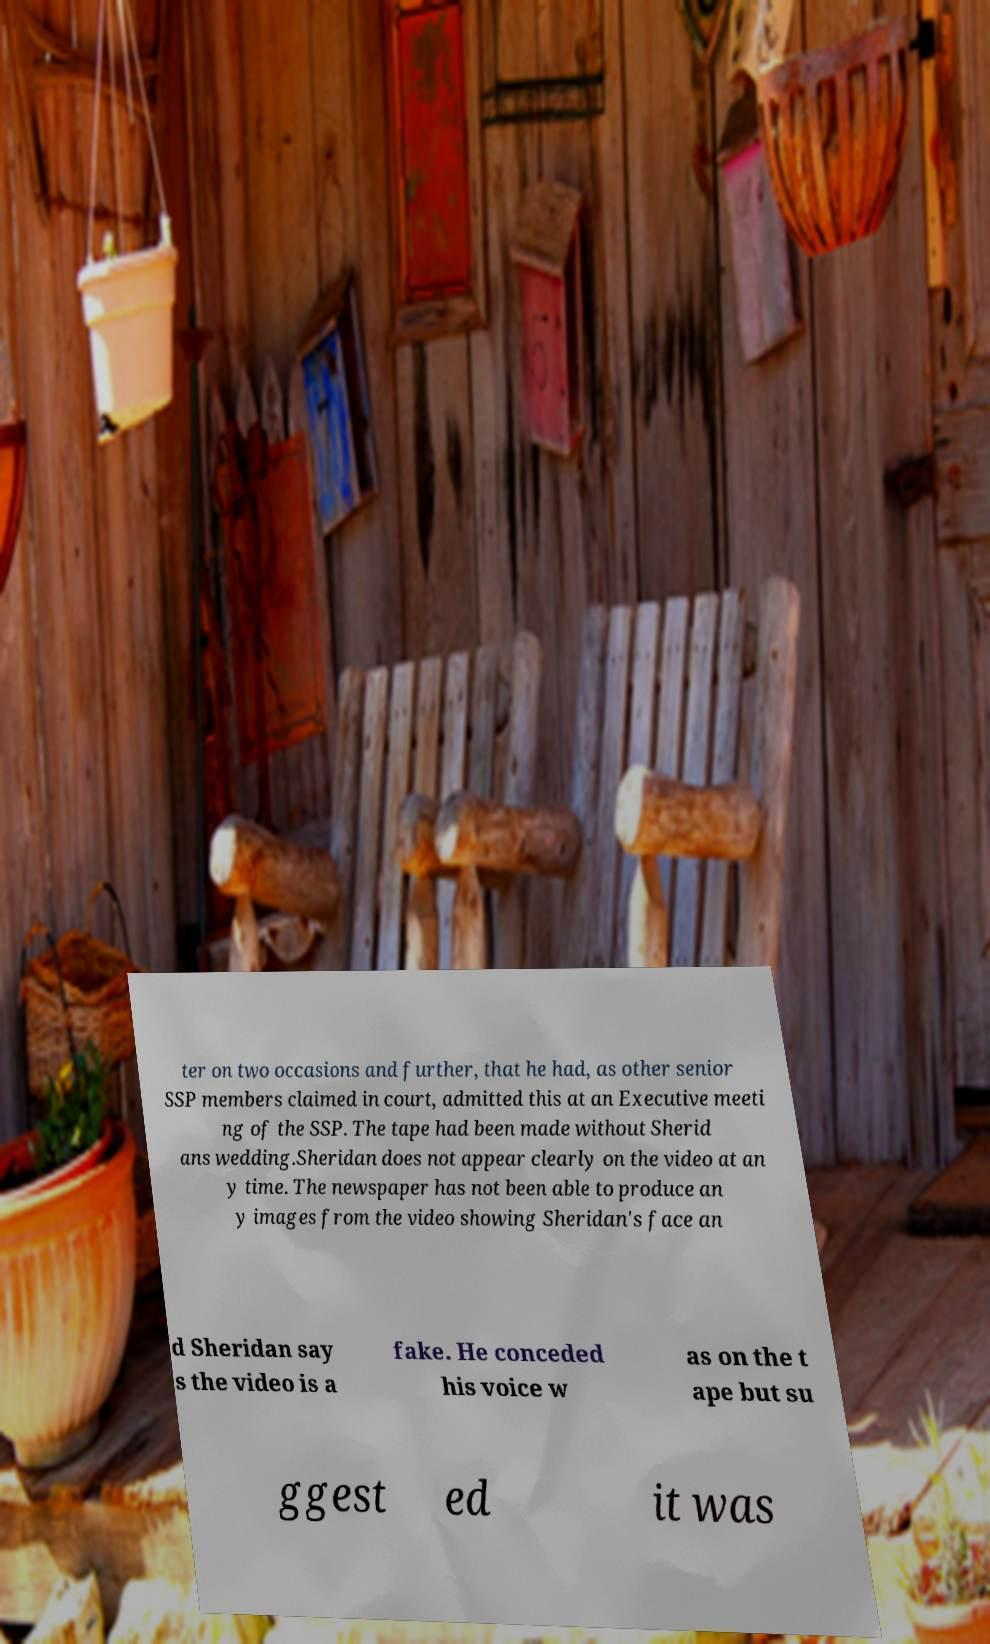Please read and relay the text visible in this image. What does it say? ter on two occasions and further, that he had, as other senior SSP members claimed in court, admitted this at an Executive meeti ng of the SSP. The tape had been made without Sherid ans wedding.Sheridan does not appear clearly on the video at an y time. The newspaper has not been able to produce an y images from the video showing Sheridan's face an d Sheridan say s the video is a fake. He conceded his voice w as on the t ape but su ggest ed it was 